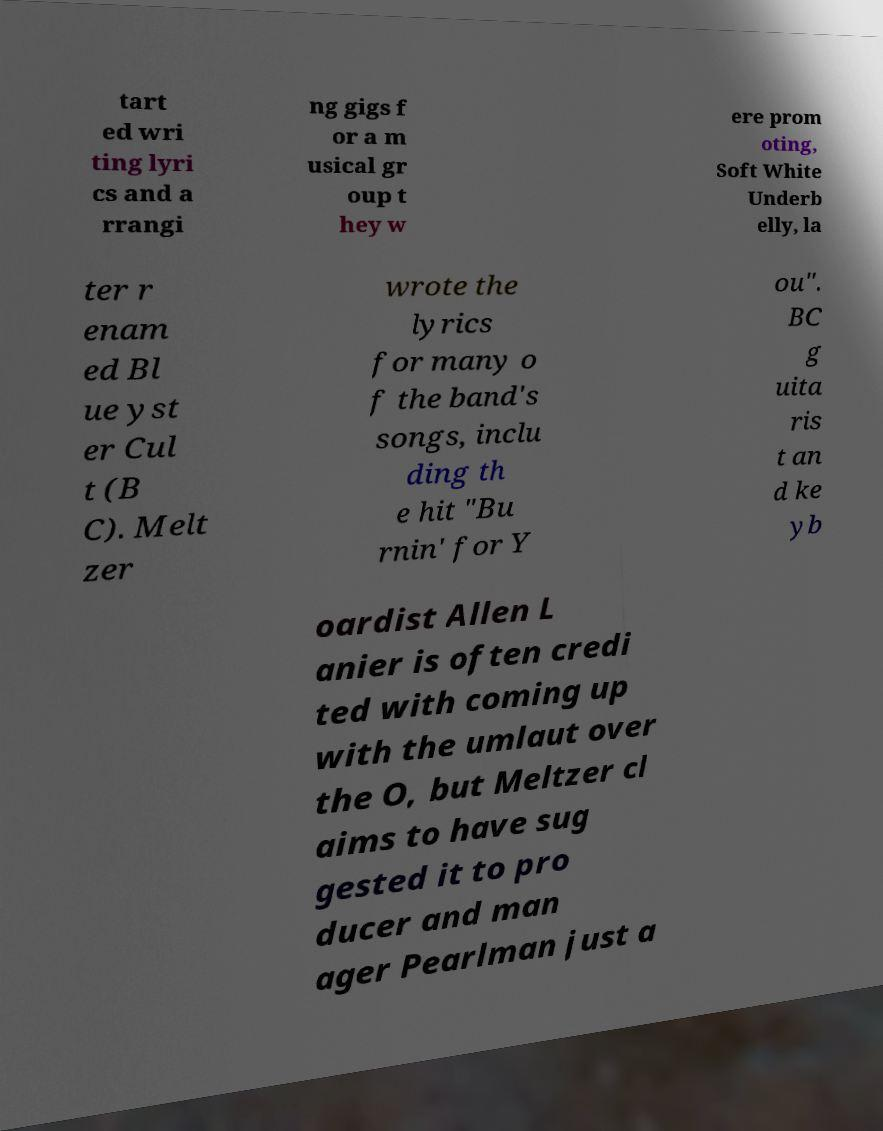For documentation purposes, I need the text within this image transcribed. Could you provide that? tart ed wri ting lyri cs and a rrangi ng gigs f or a m usical gr oup t hey w ere prom oting, Soft White Underb elly, la ter r enam ed Bl ue yst er Cul t (B C). Melt zer wrote the lyrics for many o f the band's songs, inclu ding th e hit "Bu rnin' for Y ou". BC g uita ris t an d ke yb oardist Allen L anier is often credi ted with coming up with the umlaut over the O, but Meltzer cl aims to have sug gested it to pro ducer and man ager Pearlman just a 